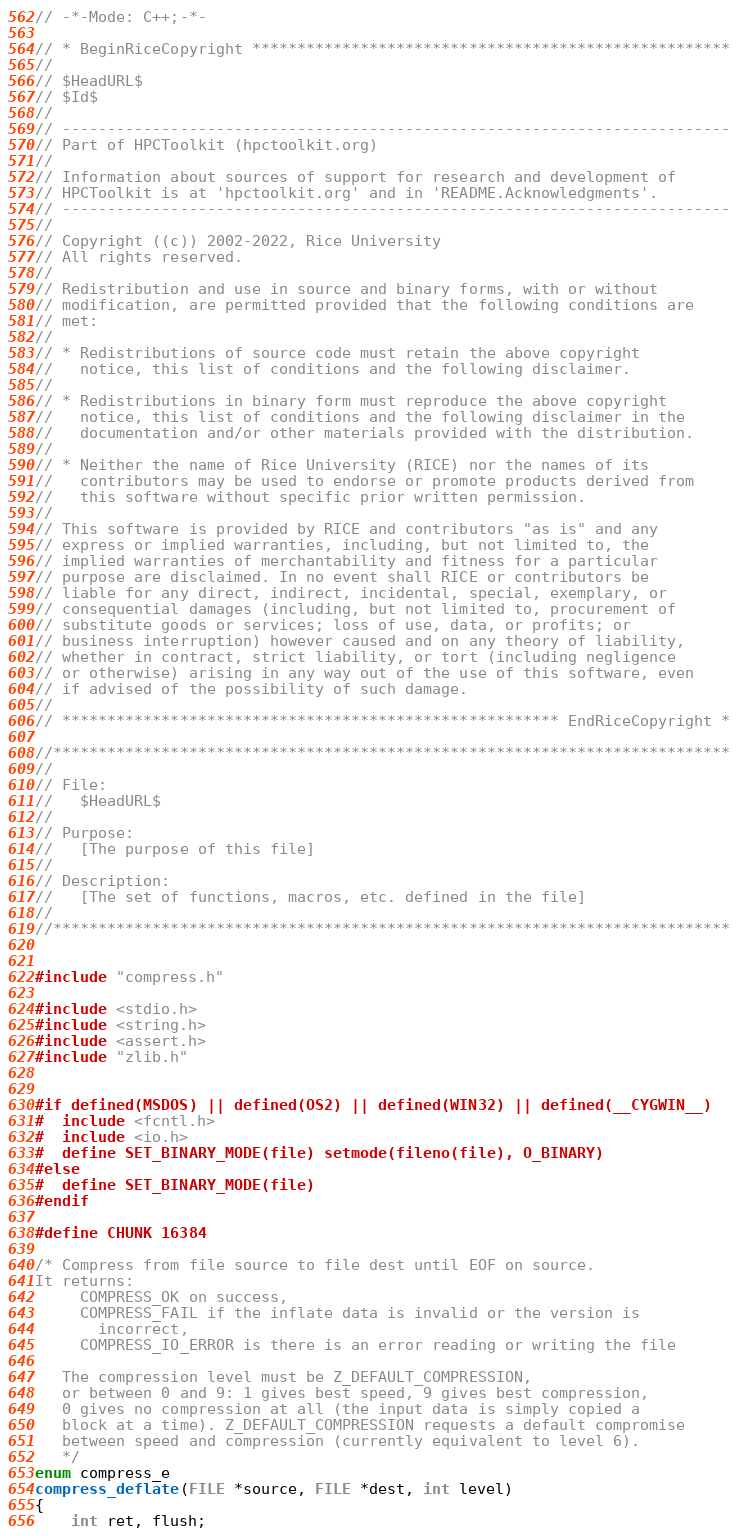Convert code to text. <code><loc_0><loc_0><loc_500><loc_500><_C_>// -*-Mode: C++;-*-

// * BeginRiceCopyright *****************************************************
//
// $HeadURL$
// $Id$
//
// --------------------------------------------------------------------------
// Part of HPCToolkit (hpctoolkit.org)
//
// Information about sources of support for research and development of
// HPCToolkit is at 'hpctoolkit.org' and in 'README.Acknowledgments'.
// --------------------------------------------------------------------------
//
// Copyright ((c)) 2002-2022, Rice University
// All rights reserved.
//
// Redistribution and use in source and binary forms, with or without
// modification, are permitted provided that the following conditions are
// met:
//
// * Redistributions of source code must retain the above copyright
//   notice, this list of conditions and the following disclaimer.
//
// * Redistributions in binary form must reproduce the above copyright
//   notice, this list of conditions and the following disclaimer in the
//   documentation and/or other materials provided with the distribution.
//
// * Neither the name of Rice University (RICE) nor the names of its
//   contributors may be used to endorse or promote products derived from
//   this software without specific prior written permission.
//
// This software is provided by RICE and contributors "as is" and any
// express or implied warranties, including, but not limited to, the
// implied warranties of merchantability and fitness for a particular
// purpose are disclaimed. In no event shall RICE or contributors be
// liable for any direct, indirect, incidental, special, exemplary, or
// consequential damages (including, but not limited to, procurement of
// substitute goods or services; loss of use, data, or profits; or
// business interruption) however caused and on any theory of liability,
// whether in contract, strict liability, or tort (including negligence
// or otherwise) arising in any way out of the use of this software, even
// if advised of the possibility of such damage.
//
// ******************************************************* EndRiceCopyright *

//***************************************************************************
//
// File:
//   $HeadURL$
//
// Purpose:
//   [The purpose of this file]
//
// Description:
//   [The set of functions, macros, etc. defined in the file]
//
//***************************************************************************


#include "compress.h"

#include <stdio.h>
#include <string.h>
#include <assert.h>
#include "zlib.h"


#if defined(MSDOS) || defined(OS2) || defined(WIN32) || defined(__CYGWIN__)
#  include <fcntl.h>
#  include <io.h>
#  define SET_BINARY_MODE(file) setmode(fileno(file), O_BINARY)
#else
#  define SET_BINARY_MODE(file)
#endif

#define CHUNK 16384

/* Compress from file source to file dest until EOF on source.
It returns:
     COMPRESS_OK on success,
     COMPRESS_FAIL if the inflate data is invalid or the version is
       incorrect,
     COMPRESS_IO_ERROR is there is an error reading or writing the file

   The compression level must be Z_DEFAULT_COMPRESSION,
   or between 0 and 9: 1 gives best speed, 9 gives best compression,
   0 gives no compression at all (the input data is simply copied a
   block at a time). Z_DEFAULT_COMPRESSION requests a default compromise
   between speed and compression (currently equivalent to level 6).
   */
enum compress_e
compress_deflate(FILE *source, FILE *dest, int level)
{
    int ret, flush;</code> 